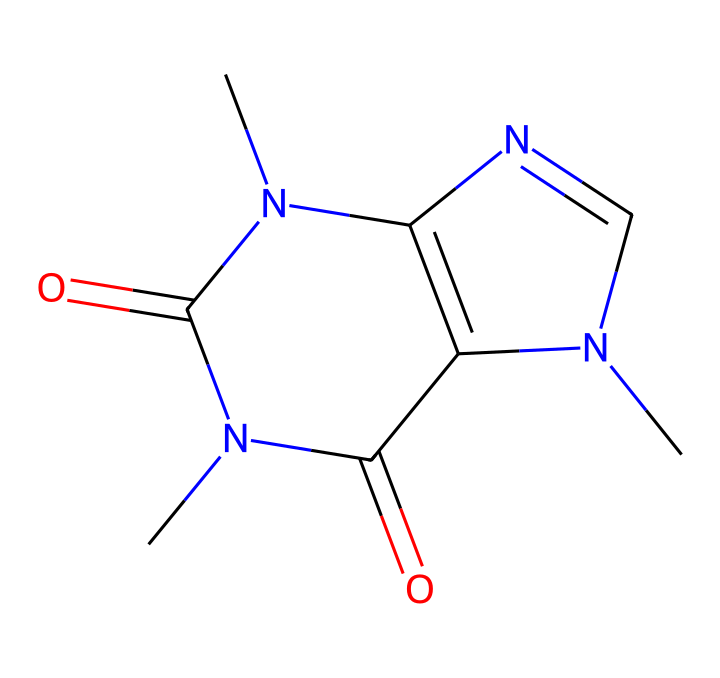What is the molecular formula of caffeine? By analyzing the SMILES representation, we can count the various atoms present. The chemical includes 8 carbon atoms, 10 hydrogen atoms, 4 nitrogen atoms, and 2 oxygen atoms. Therefore, the molecular formula is C8H10N4O2.
Answer: C8H10N4O2 How many nitrogen atoms are in caffeine? The SMILES structure shows four nitrogen atoms (N) indicated in the representation. By simply counting the 'N' characters, we can confirm this information.
Answer: 4 What type of organic compound is caffeine classified as? Caffeine contains nitrogen atoms in its structure and exhibits properties of both alkaloids and xanthines. Therefore, it is primarily classified as an alkaloid, which are nitrogen-containing compounds.
Answer: alkaloid What is the characteristic taste associated with caffeine? Caffeine, as an alkaloid, is known for its bitter taste. This is commonly experienced when consuming coffee, which contains caffeine.
Answer: bitter How many rings are present in the structure of caffeine? The SMILES notation indicates a bicyclic structure, as we see two interconnected rings represented in the layout. By analyzing the cyclic components in the formula, we can derive that there are two rings present.
Answer: 2 What functional groups are indicated in the structure of caffeine? By evaluating the SMILES structure, we can identify carbonyl groups (C=O) and amine groups (N), which together characterize the functional groups present in caffeine.
Answer: carbonyl and amine 